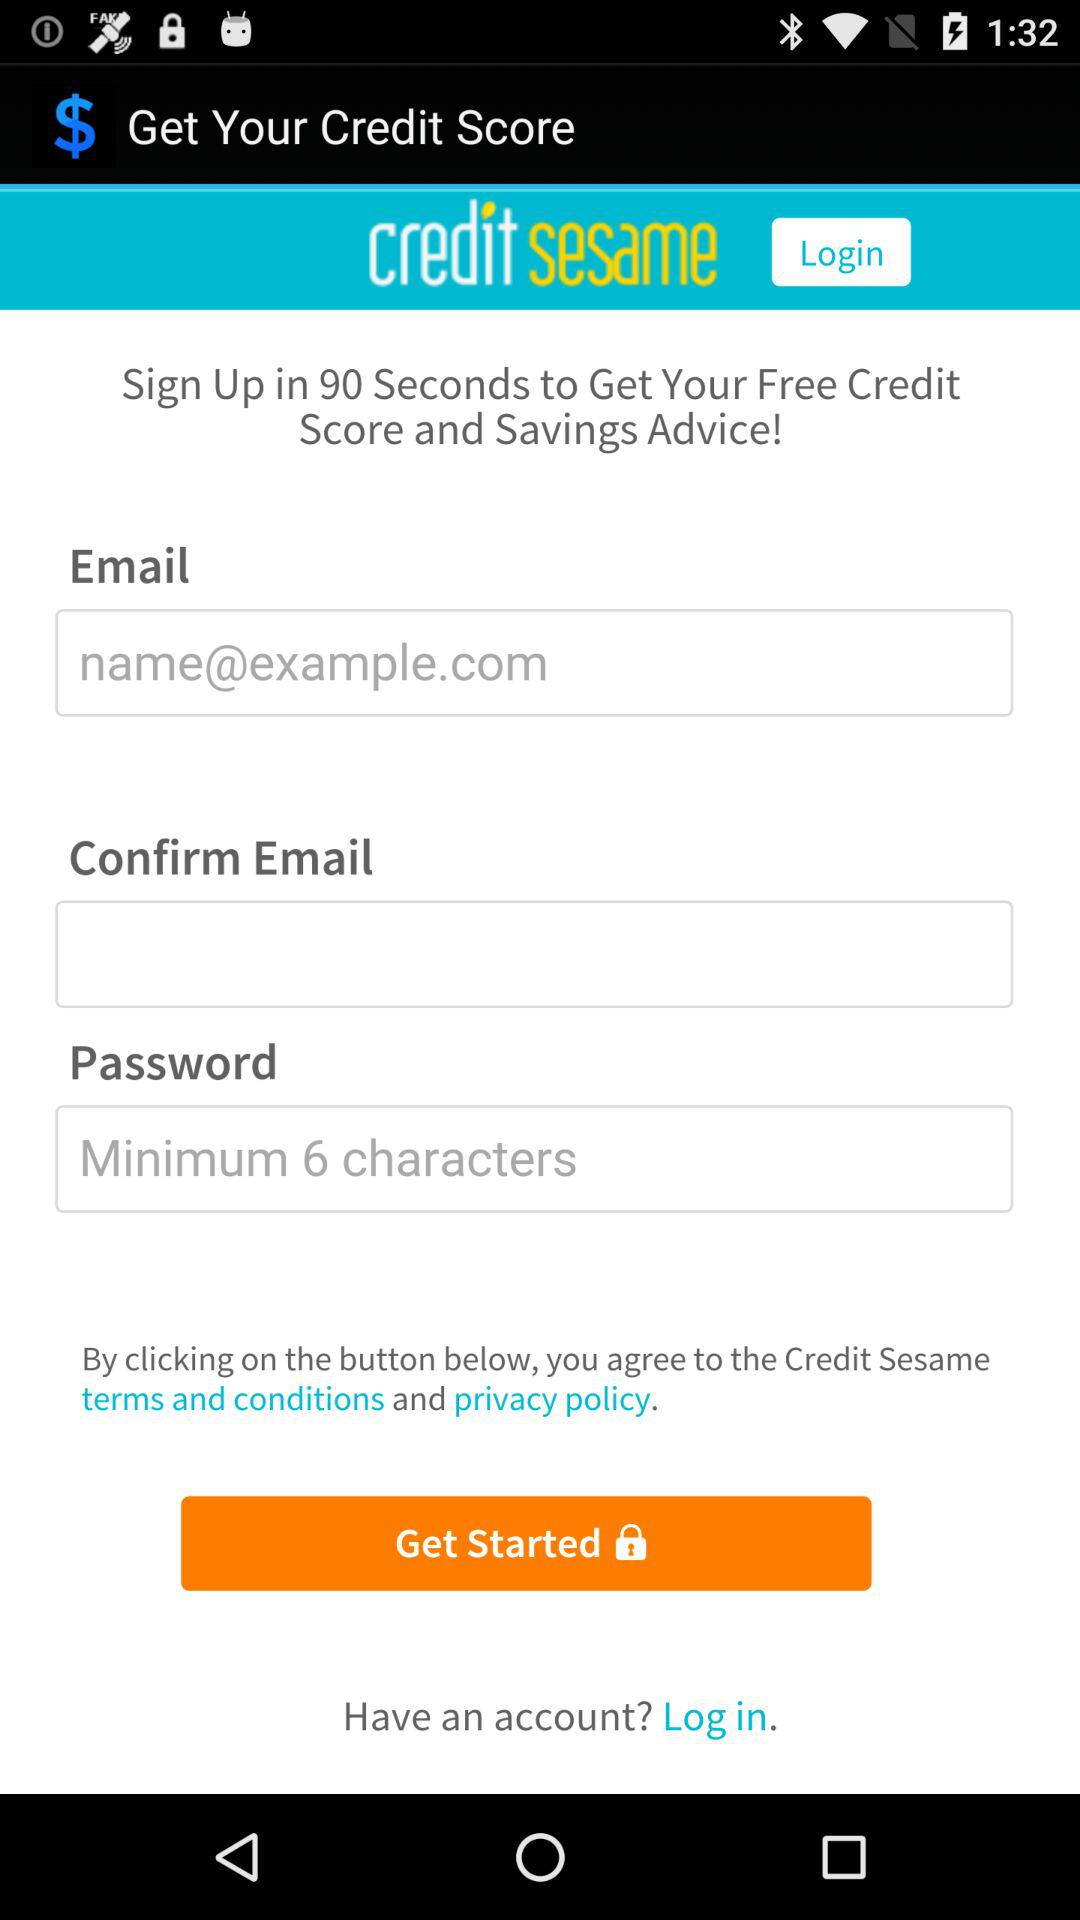How many minimum characters should be in a password? There should be minimum 6 characters. 